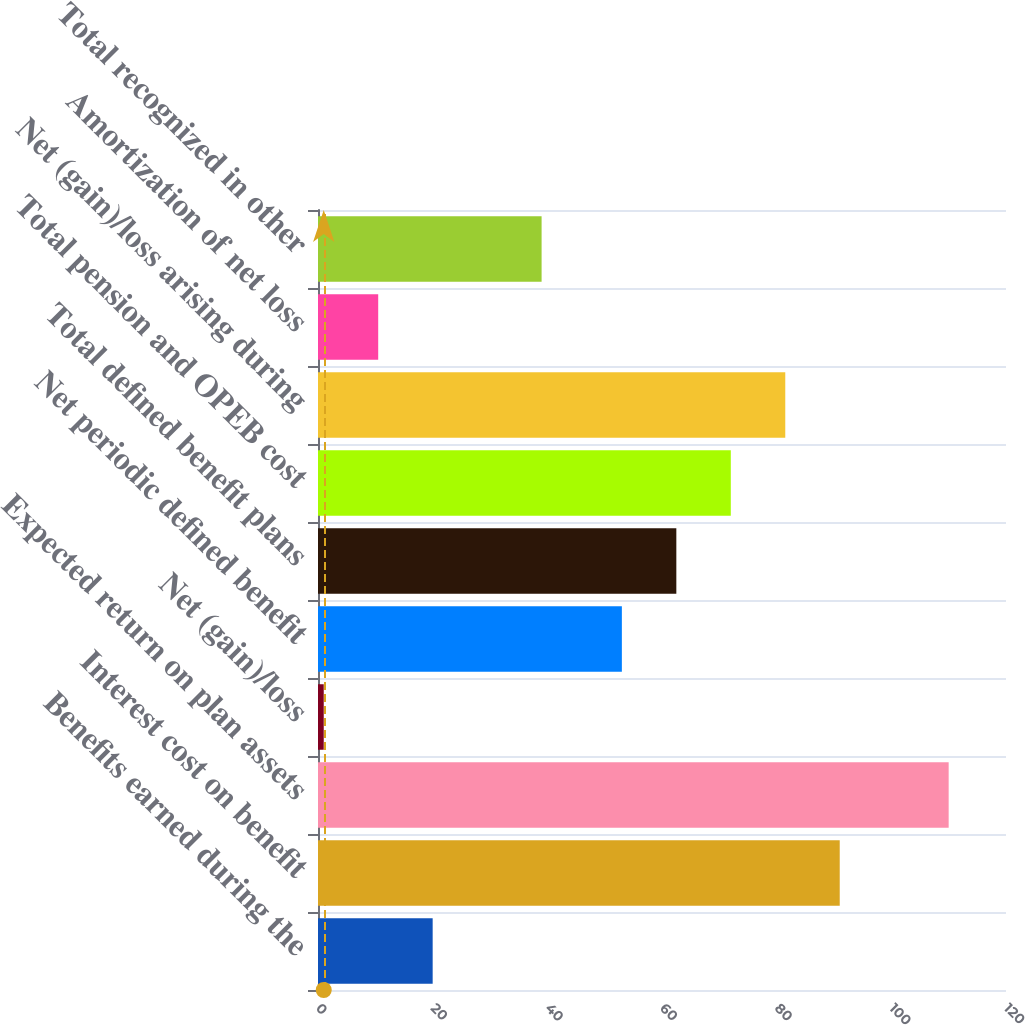Convert chart to OTSL. <chart><loc_0><loc_0><loc_500><loc_500><bar_chart><fcel>Benefits earned during the<fcel>Interest cost on benefit<fcel>Expected return on plan assets<fcel>Net (gain)/loss<fcel>Net periodic defined benefit<fcel>Total defined benefit plans<fcel>Total pension and OPEB cost<fcel>Net (gain)/loss arising during<fcel>Amortization of net loss<fcel>Total recognized in other<nl><fcel>20<fcel>91<fcel>110<fcel>1<fcel>53<fcel>62.5<fcel>72<fcel>81.5<fcel>10.5<fcel>39<nl></chart> 